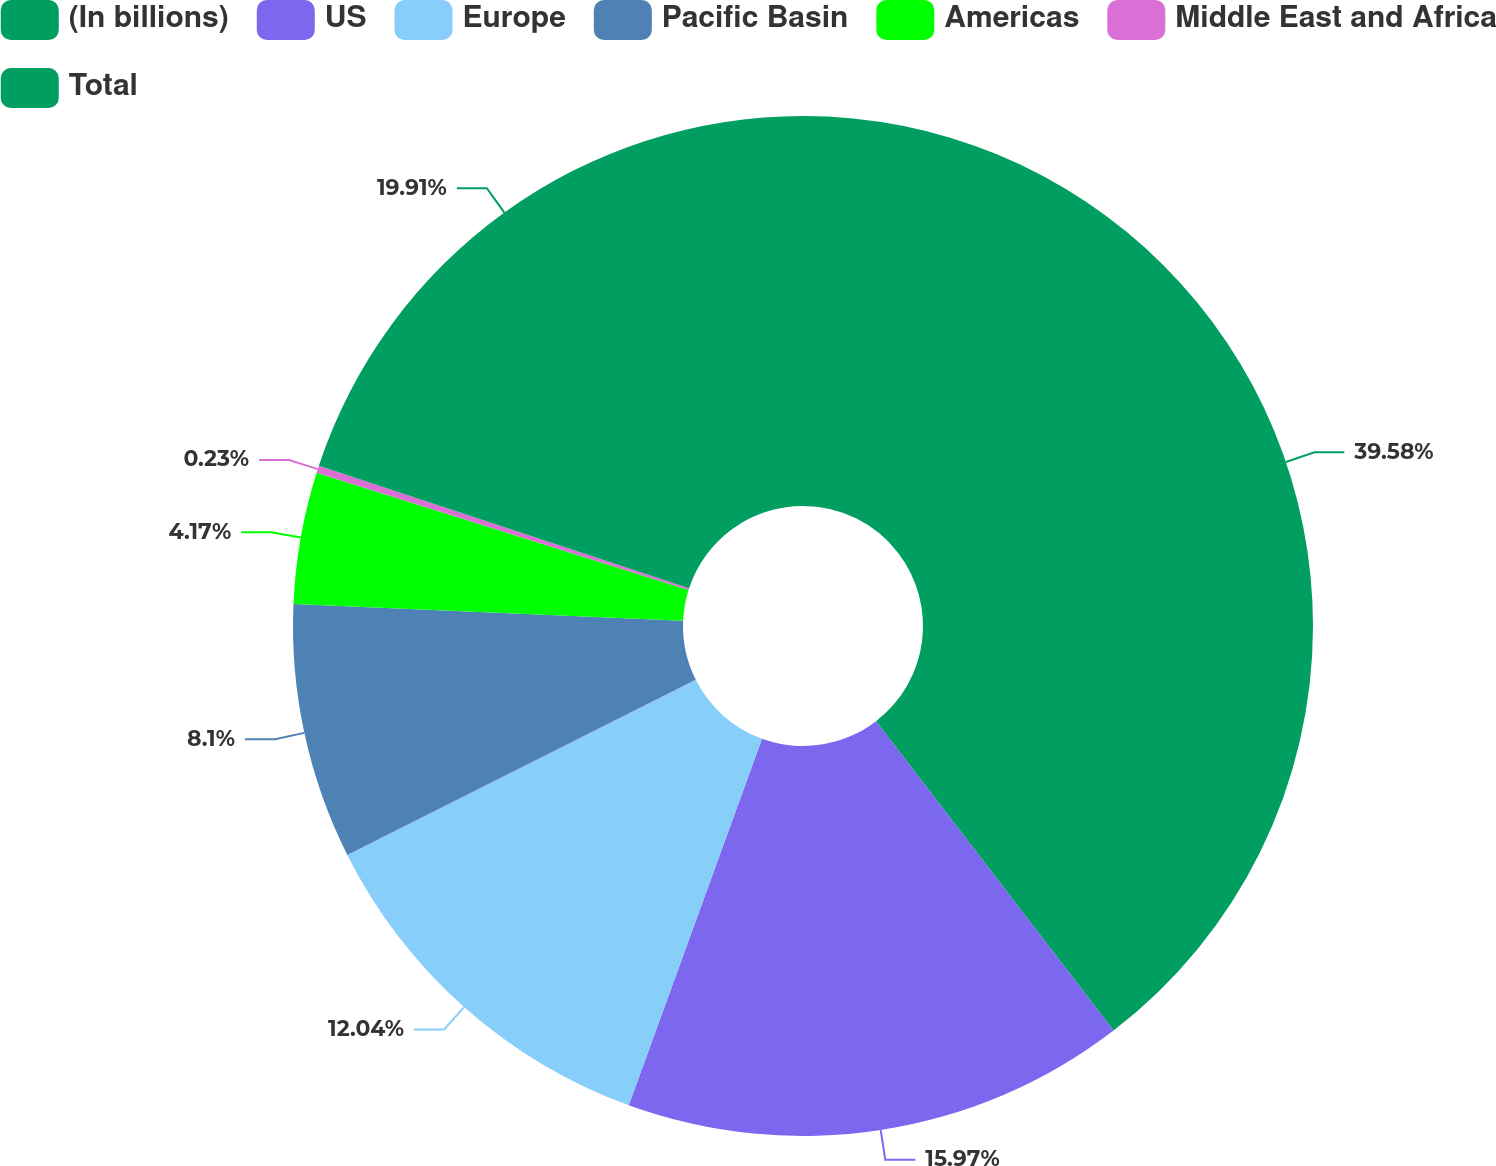Convert chart. <chart><loc_0><loc_0><loc_500><loc_500><pie_chart><fcel>(In billions)<fcel>US<fcel>Europe<fcel>Pacific Basin<fcel>Americas<fcel>Middle East and Africa<fcel>Total<nl><fcel>39.58%<fcel>15.97%<fcel>12.04%<fcel>8.1%<fcel>4.17%<fcel>0.23%<fcel>19.91%<nl></chart> 